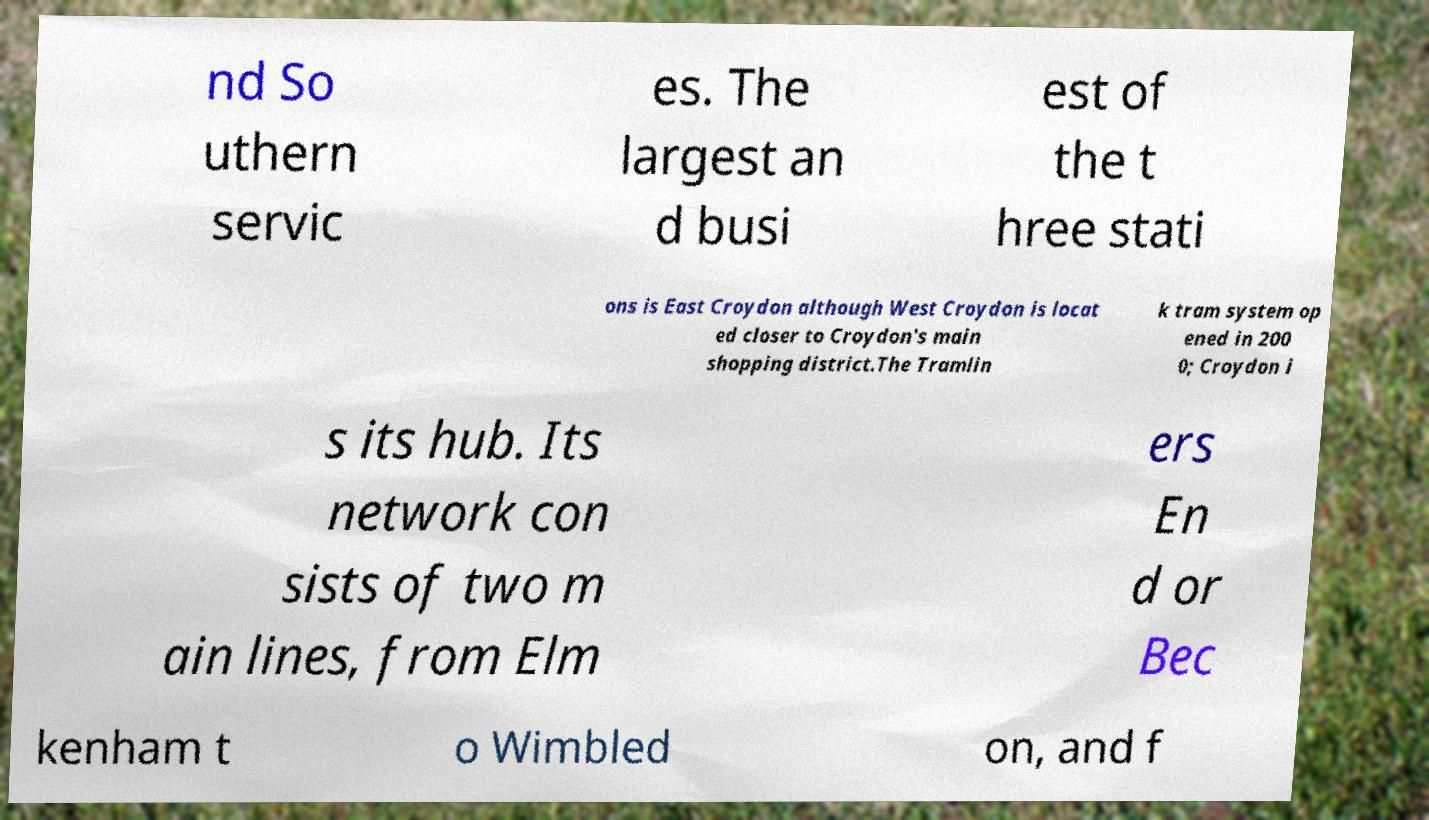I need the written content from this picture converted into text. Can you do that? nd So uthern servic es. The largest an d busi est of the t hree stati ons is East Croydon although West Croydon is locat ed closer to Croydon's main shopping district.The Tramlin k tram system op ened in 200 0; Croydon i s its hub. Its network con sists of two m ain lines, from Elm ers En d or Bec kenham t o Wimbled on, and f 